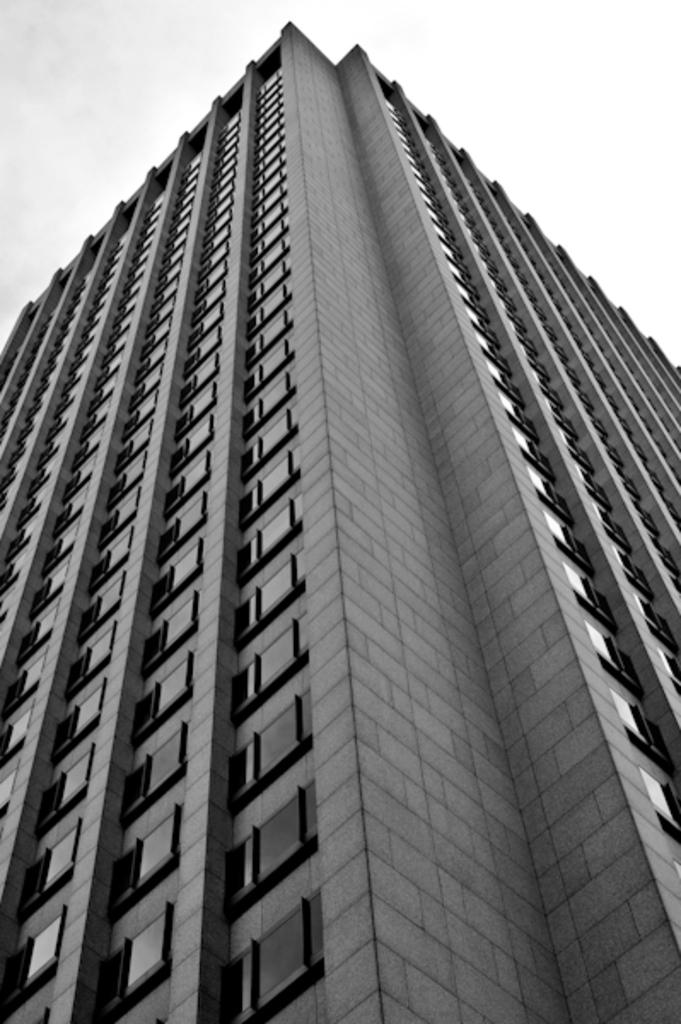What type of structure is the main subject of the picture? There is a tower building in the picture. What feature can be observed on the tower building? The tower building has glass windows. What can be seen in the sky in the picture? There are clouds in the sky. Where is the drawer located in the picture? There is no drawer present in the picture; it features a tower building with glass windows and clouds in the sky. What country is depicted in the picture? The picture does not depict a specific country; it shows a tower building with glass windows and clouds in the sky. 